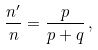<formula> <loc_0><loc_0><loc_500><loc_500>\frac { n ^ { \prime } } { n } = \frac { p } { p + q } \, ,</formula> 